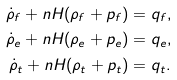<formula> <loc_0><loc_0><loc_500><loc_500>\dot { \rho } _ { f } + n H ( \rho _ { f } + p _ { f } ) & = q _ { f } , \\ \dot { \rho } _ { e } + n H ( \rho _ { e } + p _ { e } ) & = q _ { e } , \\ \dot { \rho } _ { t } + n H ( \rho _ { t } + p _ { t } ) & = q _ { t } .</formula> 